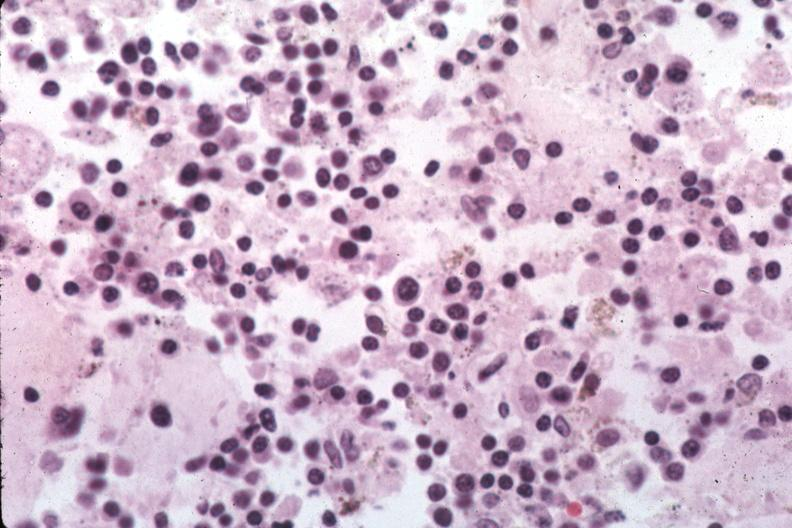s lymphangiomatosis generalized present?
Answer the question using a single word or phrase. No 